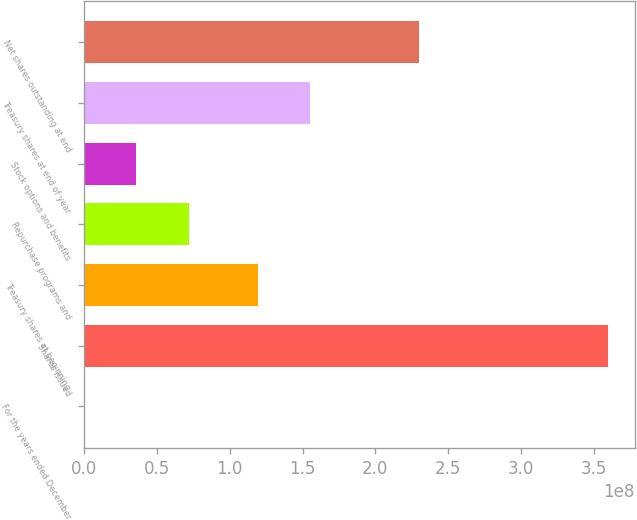<chart> <loc_0><loc_0><loc_500><loc_500><bar_chart><fcel>For the years ended December<fcel>Shares issued<fcel>Treasury shares at beginning<fcel>Repurchase programs and<fcel>Stock options and benefits<fcel>Treasury shares at end of year<fcel>Net shares outstanding at end<nl><fcel>2006<fcel>3.59902e+08<fcel>1.19378e+08<fcel>7.1982e+07<fcel>3.5992e+07<fcel>1.55368e+08<fcel>2.30264e+08<nl></chart> 